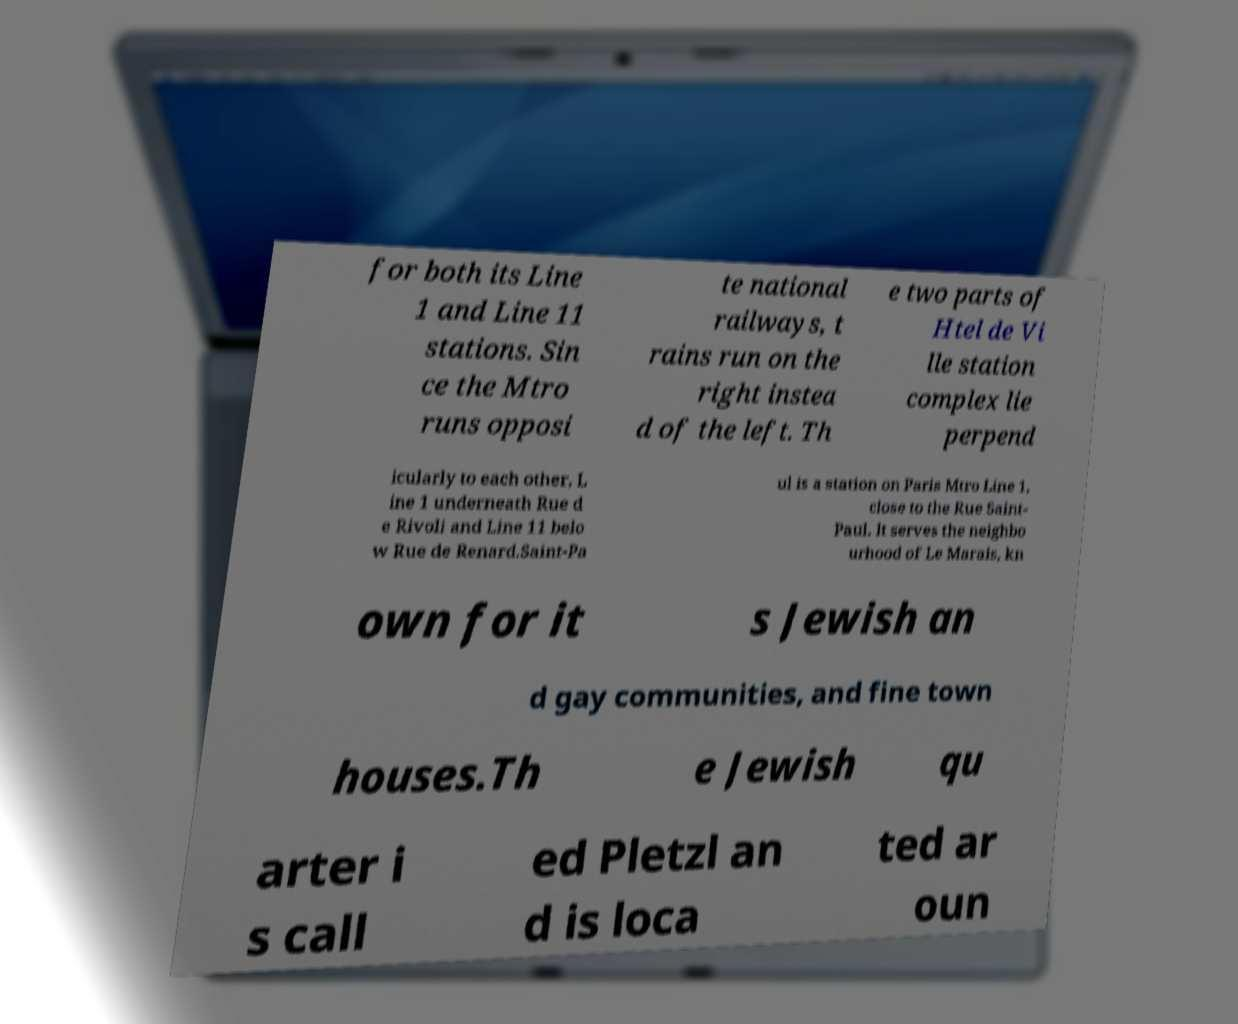For documentation purposes, I need the text within this image transcribed. Could you provide that? for both its Line 1 and Line 11 stations. Sin ce the Mtro runs opposi te national railways, t rains run on the right instea d of the left. Th e two parts of Htel de Vi lle station complex lie perpend icularly to each other, L ine 1 underneath Rue d e Rivoli and Line 11 belo w Rue de Renard.Saint-Pa ul is a station on Paris Mtro Line 1, close to the Rue Saint- Paul. It serves the neighbo urhood of Le Marais, kn own for it s Jewish an d gay communities, and fine town houses.Th e Jewish qu arter i s call ed Pletzl an d is loca ted ar oun 